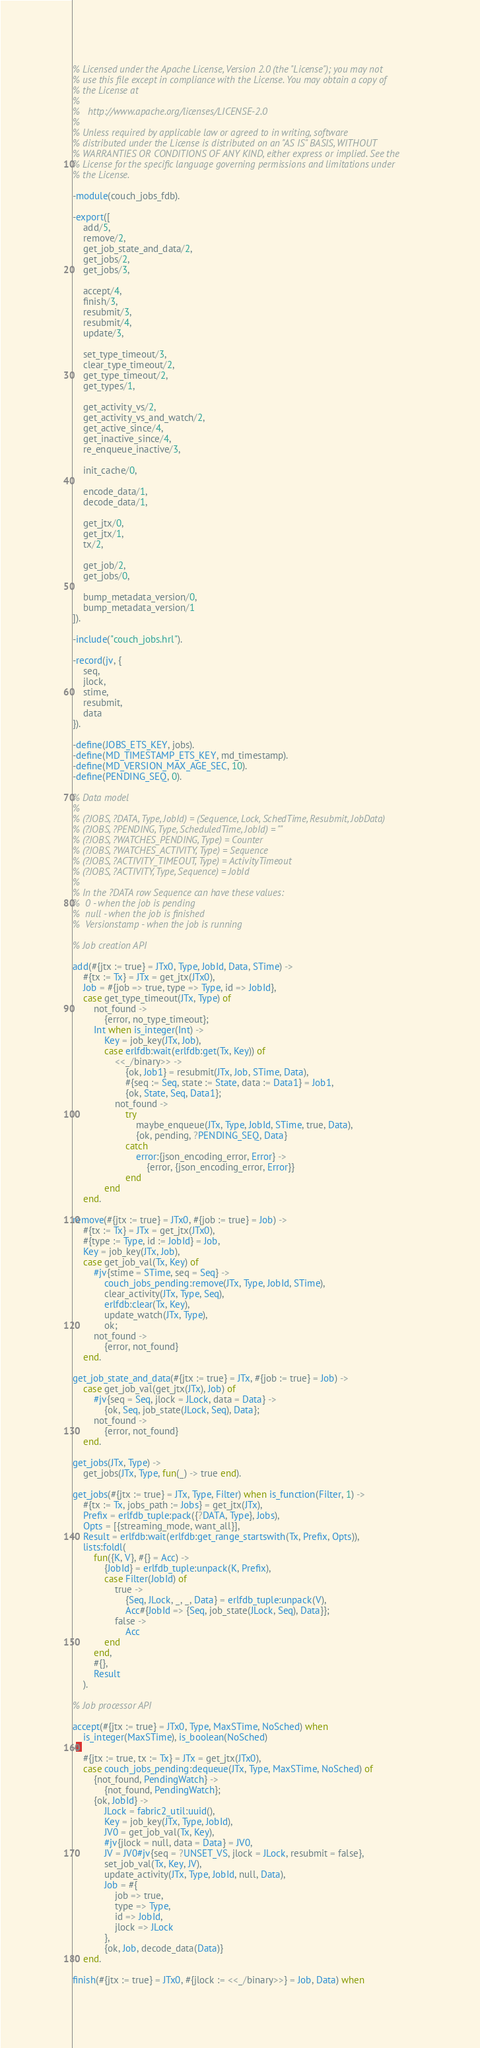<code> <loc_0><loc_0><loc_500><loc_500><_Erlang_>% Licensed under the Apache License, Version 2.0 (the "License"); you may not
% use this file except in compliance with the License. You may obtain a copy of
% the License at
%
%   http://www.apache.org/licenses/LICENSE-2.0
%
% Unless required by applicable law or agreed to in writing, software
% distributed under the License is distributed on an "AS IS" BASIS, WITHOUT
% WARRANTIES OR CONDITIONS OF ANY KIND, either express or implied. See the
% License for the specific language governing permissions and limitations under
% the License.

-module(couch_jobs_fdb).

-export([
    add/5,
    remove/2,
    get_job_state_and_data/2,
    get_jobs/2,
    get_jobs/3,

    accept/4,
    finish/3,
    resubmit/3,
    resubmit/4,
    update/3,

    set_type_timeout/3,
    clear_type_timeout/2,
    get_type_timeout/2,
    get_types/1,

    get_activity_vs/2,
    get_activity_vs_and_watch/2,
    get_active_since/4,
    get_inactive_since/4,
    re_enqueue_inactive/3,

    init_cache/0,

    encode_data/1,
    decode_data/1,

    get_jtx/0,
    get_jtx/1,
    tx/2,

    get_job/2,
    get_jobs/0,

    bump_metadata_version/0,
    bump_metadata_version/1
]).

-include("couch_jobs.hrl").

-record(jv, {
    seq,
    jlock,
    stime,
    resubmit,
    data
}).

-define(JOBS_ETS_KEY, jobs).
-define(MD_TIMESTAMP_ETS_KEY, md_timestamp).
-define(MD_VERSION_MAX_AGE_SEC, 10).
-define(PENDING_SEQ, 0).

% Data model
%
% (?JOBS, ?DATA, Type, JobId) = (Sequence, Lock, SchedTime, Resubmit, JobData)
% (?JOBS, ?PENDING, Type, ScheduledTime, JobId) = ""
% (?JOBS, ?WATCHES_PENDING, Type) = Counter
% (?JOBS, ?WATCHES_ACTIVITY, Type) = Sequence
% (?JOBS, ?ACTIVITY_TIMEOUT, Type) = ActivityTimeout
% (?JOBS, ?ACTIVITY, Type, Sequence) = JobId
%
% In the ?DATA row Sequence can have these values:
%  0 - when the job is pending
%  null - when the job is finished
%  Versionstamp - when the job is running

% Job creation API

add(#{jtx := true} = JTx0, Type, JobId, Data, STime) ->
    #{tx := Tx} = JTx = get_jtx(JTx0),
    Job = #{job => true, type => Type, id => JobId},
    case get_type_timeout(JTx, Type) of
        not_found ->
            {error, no_type_timeout};
        Int when is_integer(Int) ->
            Key = job_key(JTx, Job),
            case erlfdb:wait(erlfdb:get(Tx, Key)) of
                <<_/binary>> ->
                    {ok, Job1} = resubmit(JTx, Job, STime, Data),
                    #{seq := Seq, state := State, data := Data1} = Job1,
                    {ok, State, Seq, Data1};
                not_found ->
                    try
                        maybe_enqueue(JTx, Type, JobId, STime, true, Data),
                        {ok, pending, ?PENDING_SEQ, Data}
                    catch
                        error:{json_encoding_error, Error} ->
                            {error, {json_encoding_error, Error}}
                    end
            end
    end.

remove(#{jtx := true} = JTx0, #{job := true} = Job) ->
    #{tx := Tx} = JTx = get_jtx(JTx0),
    #{type := Type, id := JobId} = Job,
    Key = job_key(JTx, Job),
    case get_job_val(Tx, Key) of
        #jv{stime = STime, seq = Seq} ->
            couch_jobs_pending:remove(JTx, Type, JobId, STime),
            clear_activity(JTx, Type, Seq),
            erlfdb:clear(Tx, Key),
            update_watch(JTx, Type),
            ok;
        not_found ->
            {error, not_found}
    end.

get_job_state_and_data(#{jtx := true} = JTx, #{job := true} = Job) ->
    case get_job_val(get_jtx(JTx), Job) of
        #jv{seq = Seq, jlock = JLock, data = Data} ->
            {ok, Seq, job_state(JLock, Seq), Data};
        not_found ->
            {error, not_found}
    end.

get_jobs(JTx, Type) ->
    get_jobs(JTx, Type, fun(_) -> true end).

get_jobs(#{jtx := true} = JTx, Type, Filter) when is_function(Filter, 1) ->
    #{tx := Tx, jobs_path := Jobs} = get_jtx(JTx),
    Prefix = erlfdb_tuple:pack({?DATA, Type}, Jobs),
    Opts = [{streaming_mode, want_all}],
    Result = erlfdb:wait(erlfdb:get_range_startswith(Tx, Prefix, Opts)),
    lists:foldl(
        fun({K, V}, #{} = Acc) ->
            {JobId} = erlfdb_tuple:unpack(K, Prefix),
            case Filter(JobId) of
                true ->
                    {Seq, JLock, _, _, Data} = erlfdb_tuple:unpack(V),
                    Acc#{JobId => {Seq, job_state(JLock, Seq), Data}};
                false ->
                    Acc
            end
        end,
        #{},
        Result
    ).

% Job processor API

accept(#{jtx := true} = JTx0, Type, MaxSTime, NoSched) when
    is_integer(MaxSTime), is_boolean(NoSched)
->
    #{jtx := true, tx := Tx} = JTx = get_jtx(JTx0),
    case couch_jobs_pending:dequeue(JTx, Type, MaxSTime, NoSched) of
        {not_found, PendingWatch} ->
            {not_found, PendingWatch};
        {ok, JobId} ->
            JLock = fabric2_util:uuid(),
            Key = job_key(JTx, Type, JobId),
            JV0 = get_job_val(Tx, Key),
            #jv{jlock = null, data = Data} = JV0,
            JV = JV0#jv{seq = ?UNSET_VS, jlock = JLock, resubmit = false},
            set_job_val(Tx, Key, JV),
            update_activity(JTx, Type, JobId, null, Data),
            Job = #{
                job => true,
                type => Type,
                id => JobId,
                jlock => JLock
            },
            {ok, Job, decode_data(Data)}
    end.

finish(#{jtx := true} = JTx0, #{jlock := <<_/binary>>} = Job, Data) when</code> 